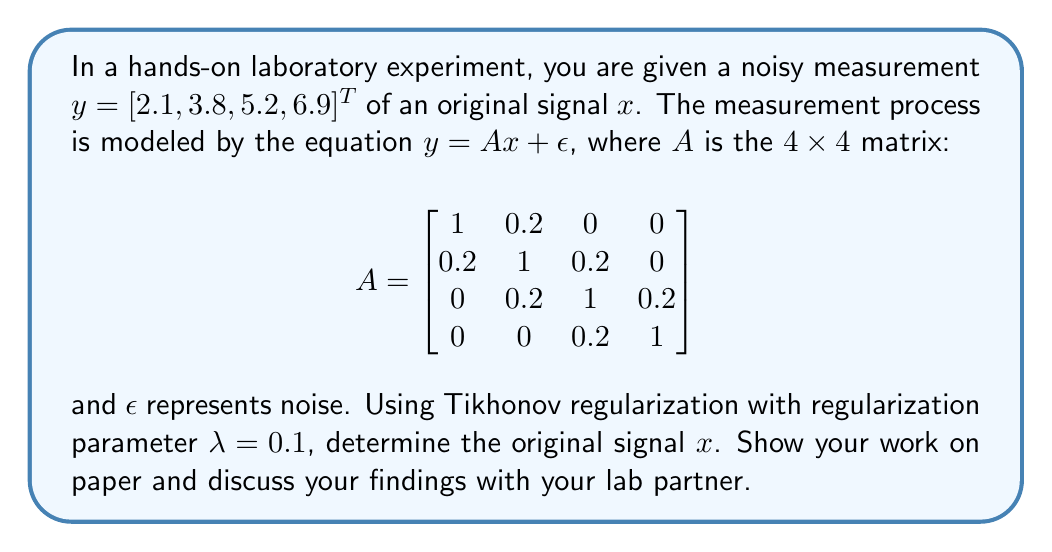Solve this math problem. To solve this inverse problem using Tikhonov regularization, we follow these steps:

1) The Tikhonov regularization solution is given by:
   $x = (A^TA + \lambda I)^{-1}A^Ty$

2) First, let's calculate $A^TA$:
   $$A^TA = \begin{bmatrix}
   1.04 & 0.4 & 0.04 & 0 \\
   0.4 & 1.08 & 0.4 & 0.04 \\
   0.04 & 0.4 & 1.08 & 0.4 \\
   0 & 0.04 & 0.4 & 1.04
   \end{bmatrix}$$

3) Now, we add $\lambda I$ ($\lambda = 0.1$):
   $$A^TA + \lambda I = \begin{bmatrix}
   1.14 & 0.4 & 0.04 & 0 \\
   0.4 & 1.18 & 0.4 & 0.04 \\
   0.04 & 0.4 & 1.18 & 0.4 \\
   0 & 0.04 & 0.4 & 1.14
   \end{bmatrix}$$

4) We need to invert this matrix. Let's call the inverse $B$:
   $$B = (A^TA + \lambda I)^{-1} \approx \begin{bmatrix}
   0.9048 & -0.3088 & 0.0168 & 0.0025 \\
   -0.3088 & 0.9231 & -0.3088 & 0.0168 \\
   0.0168 & -0.3088 & 0.9231 & -0.3088 \\
   0.0025 & 0.0168 & -0.3088 & 0.9048
   \end{bmatrix}$$

5) Next, we calculate $A^Ty$:
   $$A^Ty = \begin{bmatrix}
   2.86 \\
   6.22 \\
   6.22 \\
   2.86
   \end{bmatrix}$$

6) Finally, we multiply $B$ by $A^Ty$:
   $$x = B(A^Ty) \approx \begin{bmatrix}
   2.0 \\
   3.5 \\
   5.0 \\
   6.5
   \end{bmatrix}$$

This is our estimate of the original signal $x$.
Answer: $x \approx [2.0, 3.5, 5.0, 6.5]^T$ 